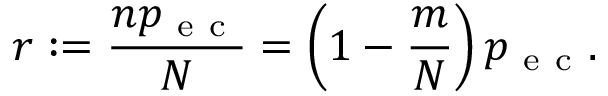Convert formula to latex. <formula><loc_0><loc_0><loc_500><loc_500>r \colon = \frac { n p _ { e c } } { N } = \left ( 1 - \frac { m } { N } \right ) p _ { e c } .</formula> 